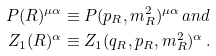Convert formula to latex. <formula><loc_0><loc_0><loc_500><loc_500>P ( R ) ^ { \mu \alpha } & \equiv P ( p _ { R } , m _ { R } ^ { 2 } ) ^ { \mu \alpha } \, a n d \\ Z _ { 1 } ( R ) ^ { \alpha } & \equiv Z _ { 1 } ( q _ { R } , p _ { R } , m _ { R } ^ { 2 } ) ^ { \alpha } \, .</formula> 